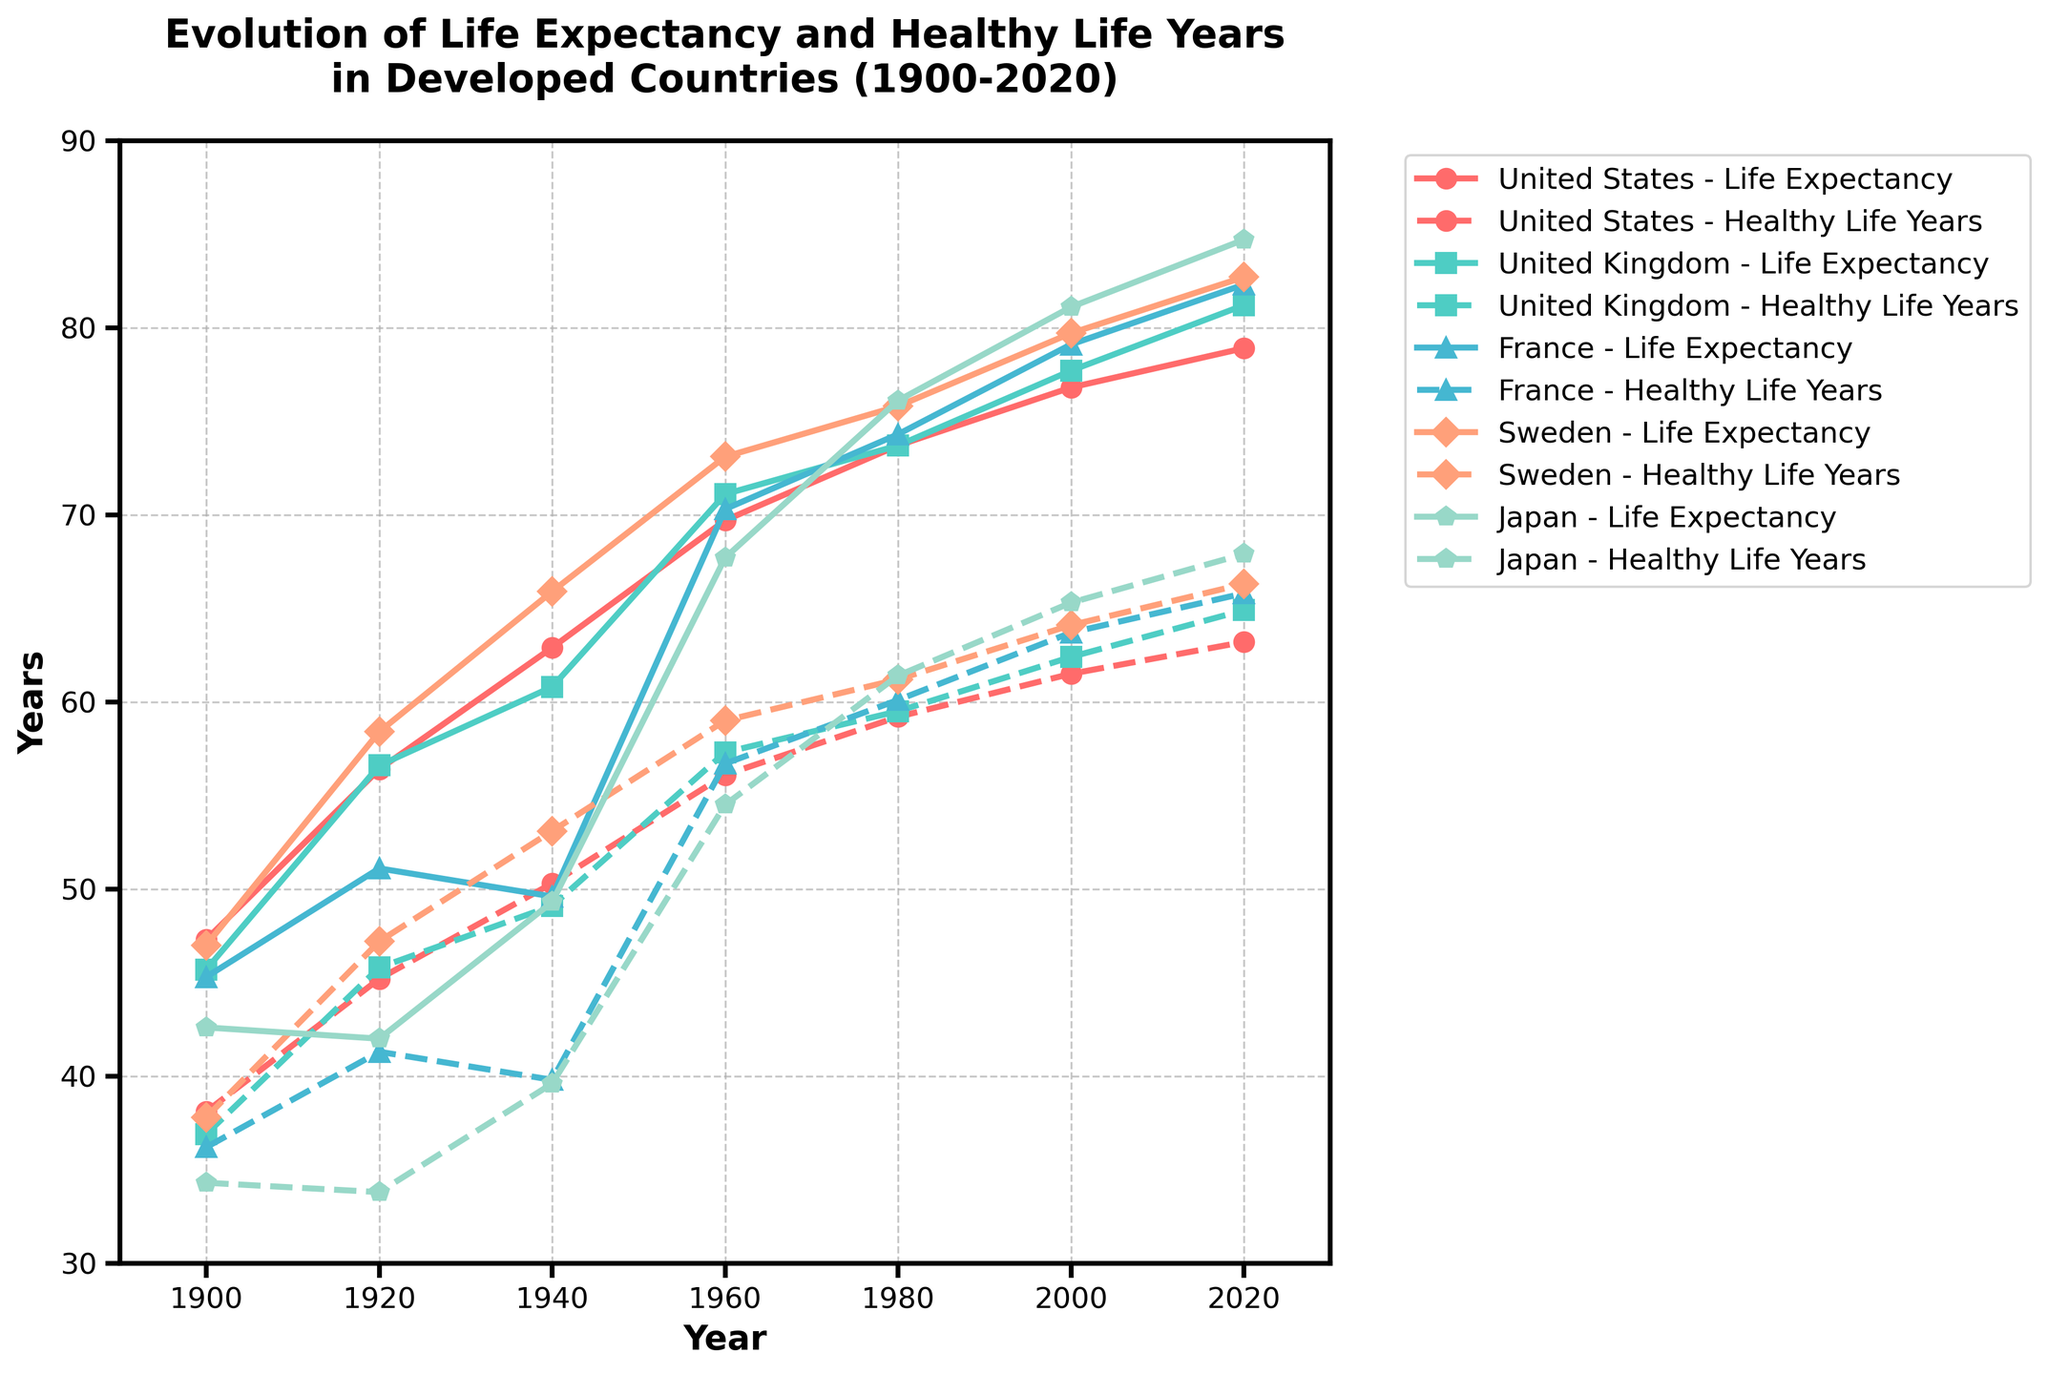What is the difference between life expectancy and healthy life years for Japan in the year 2020? First, locate the data points for Japan in the year 2020 on the plotted lines. The life expectancy for Japan is 84.7 years, and healthy life years are 67.9 years. Calculate the difference: 84.7 - 67.9 = 16.8
Answer: 16.8 Which country had the highest life expectancy in 2020? Identify the highest point on the life expectancy lines for the year 2020. From the figure, Sweden had the highest life expectancy of 82.7 years.
Answer: Sweden How has the gap between life expectancy and healthy life years changed for the United States from 1900 to 2020? For the United States in 1900, life expectancy was 47.3 years and healthy life years were 38.1, making the gap 47.3 - 38.1 = 9.2 years. In 2020, life expectancy was 78.9 years and healthy life years were 63.2, making the gap 78.9 - 63.2 = 15.7 years. Comparing the gaps: 15.7 - 9.2 = 6.5 years. The gap increased by 6.5 years.
Answer: Increased by 6.5 years Which country showed the least improvement in healthy life years from 1900 to 1940? Calculate the change in healthy life years from 1900 to 1940 for each country. United States: 50.3 - 38.1 = 12.2, United Kingdom: 49.1 - 36.9 = 12.2, France: 39.8 - 41.3 = decrease of 1.5, Sweden: 53.1 - 47.2 = 5.3, Japan: 39.6 - 33.8 = 5.8. France showed a decrease, thus the least improvement.
Answer: France Which country's life expectancy surpassed 80 years by 2020? Identify the countries with life expectancy greater than 80 years in 2020. The countries meeting this criterion in the visualization are United Kingdom (81.2 years), France (82.3 years), Sweden (82.7 years), and Japan (84.7 years).
Answer: United Kingdom, France, Sweden, Japan 